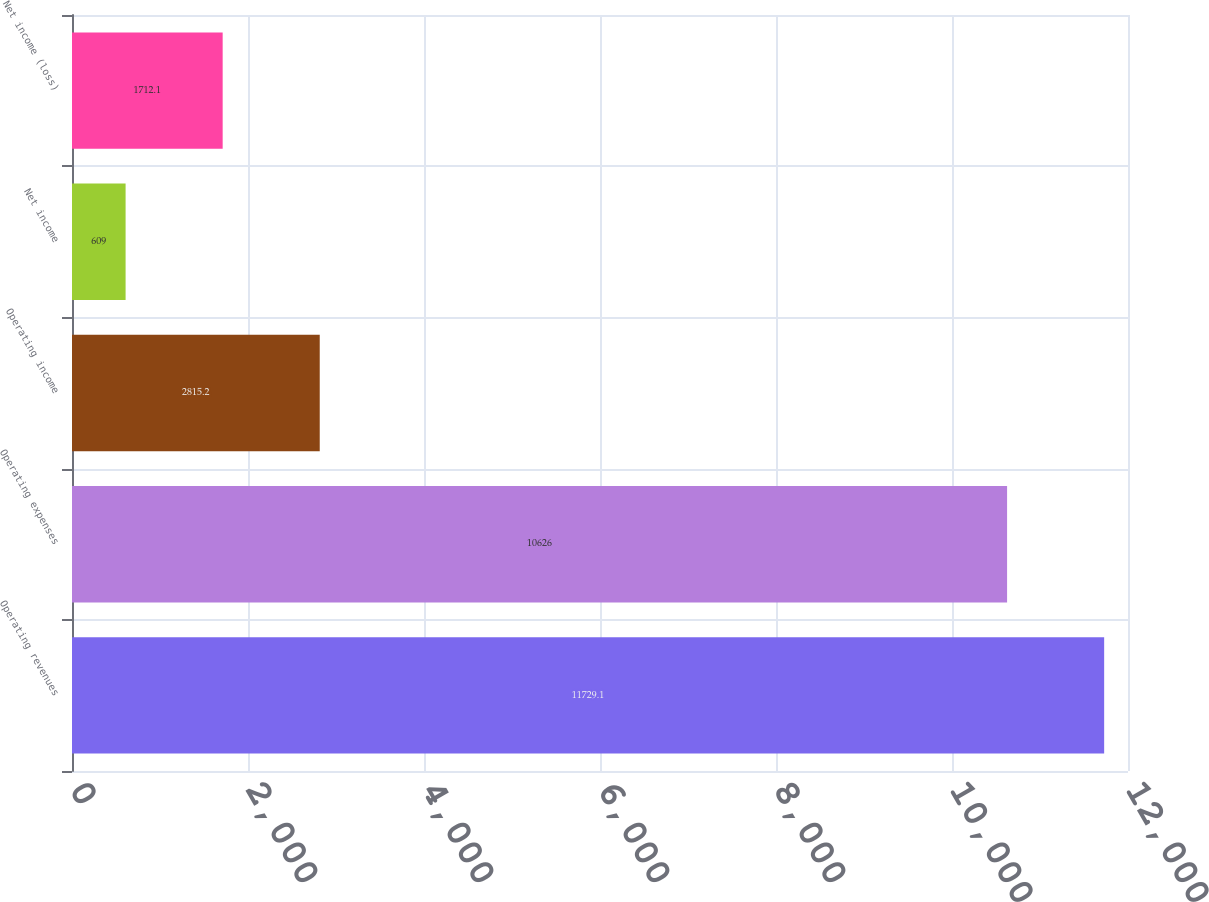Convert chart to OTSL. <chart><loc_0><loc_0><loc_500><loc_500><bar_chart><fcel>Operating revenues<fcel>Operating expenses<fcel>Operating income<fcel>Net income<fcel>Net income (loss)<nl><fcel>11729.1<fcel>10626<fcel>2815.2<fcel>609<fcel>1712.1<nl></chart> 